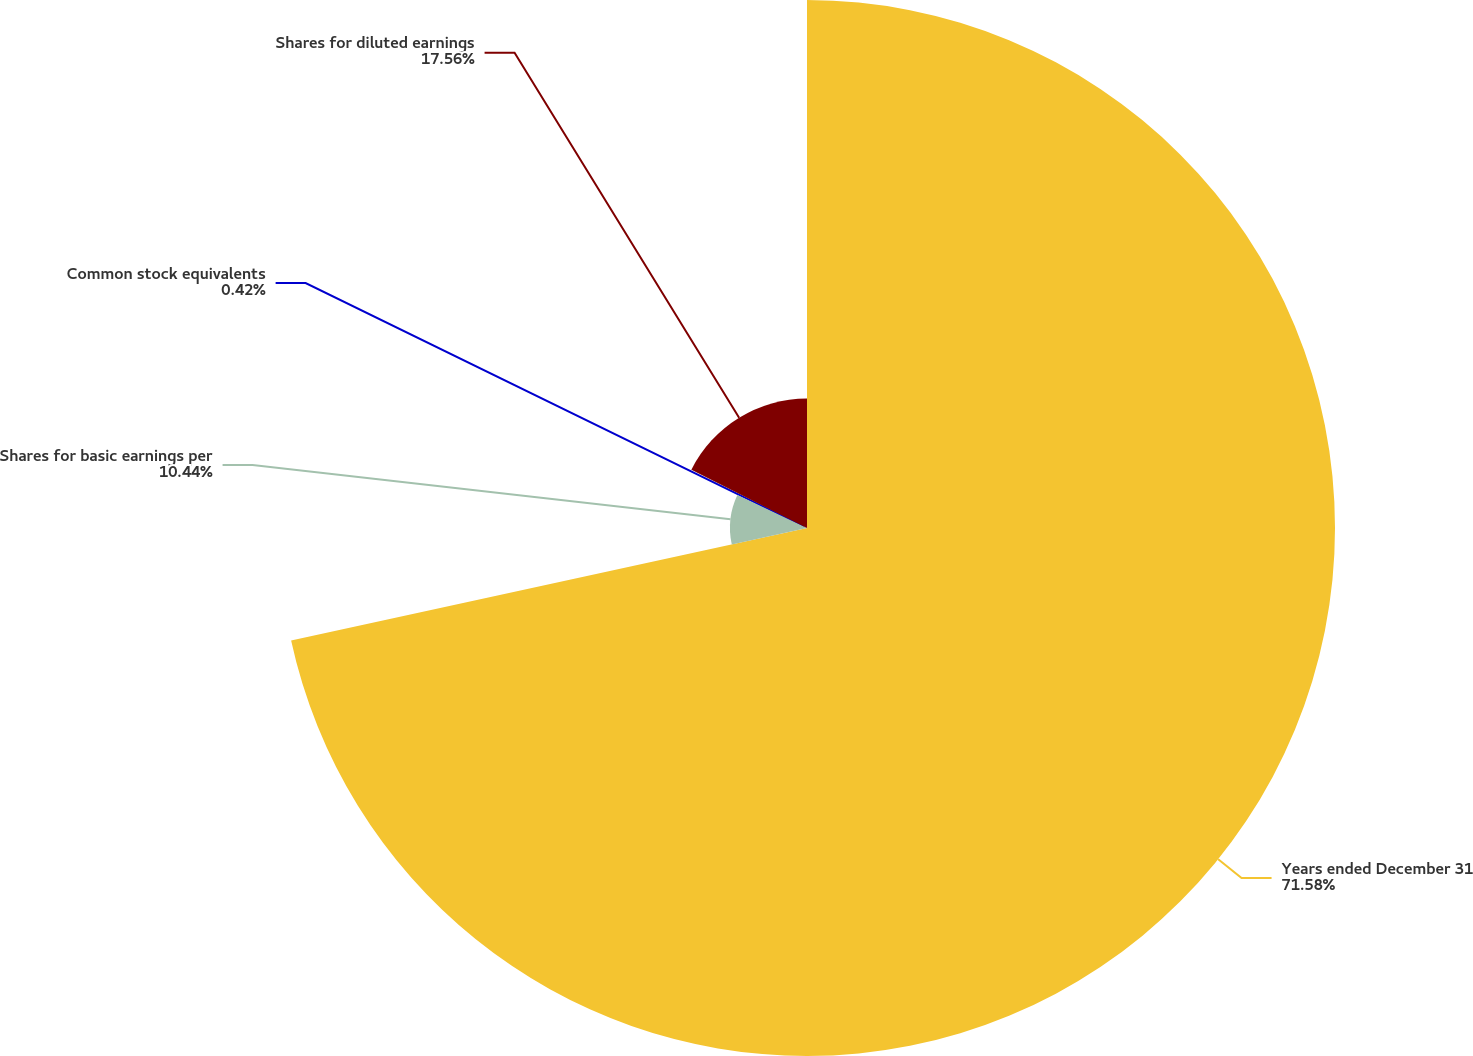Convert chart. <chart><loc_0><loc_0><loc_500><loc_500><pie_chart><fcel>Years ended December 31<fcel>Shares for basic earnings per<fcel>Common stock equivalents<fcel>Shares for diluted earnings<nl><fcel>71.59%<fcel>10.44%<fcel>0.42%<fcel>17.56%<nl></chart> 